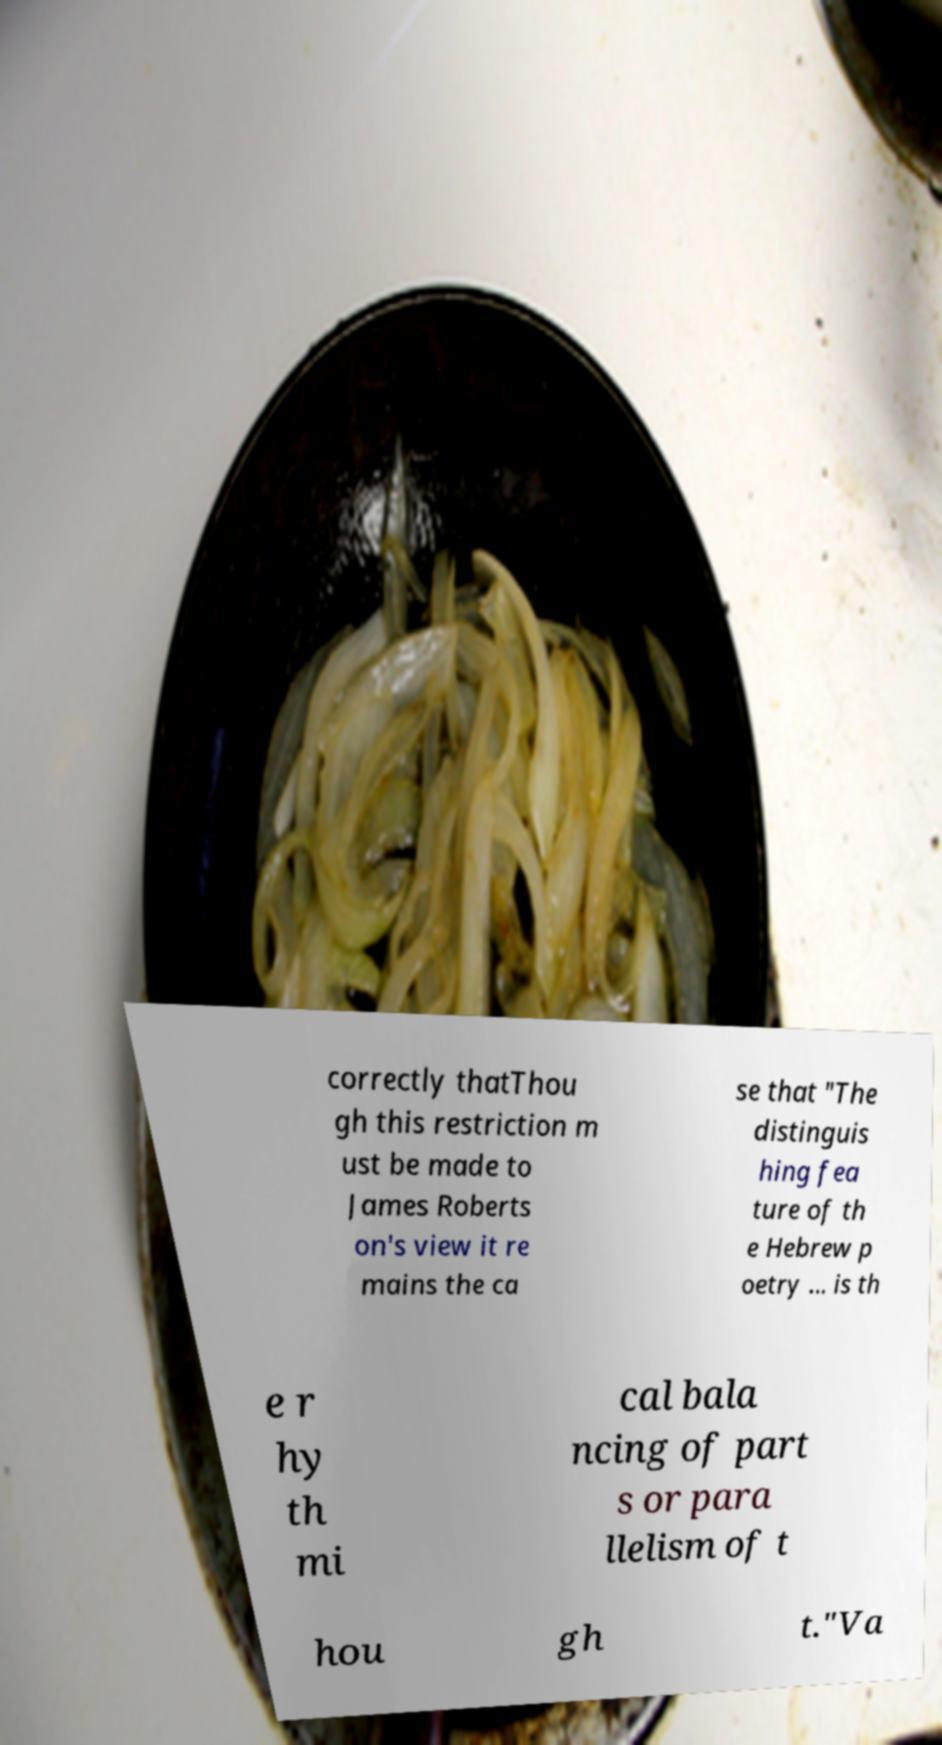I need the written content from this picture converted into text. Can you do that? correctly thatThou gh this restriction m ust be made to James Roberts on's view it re mains the ca se that "The distinguis hing fea ture of th e Hebrew p oetry ... is th e r hy th mi cal bala ncing of part s or para llelism of t hou gh t."Va 